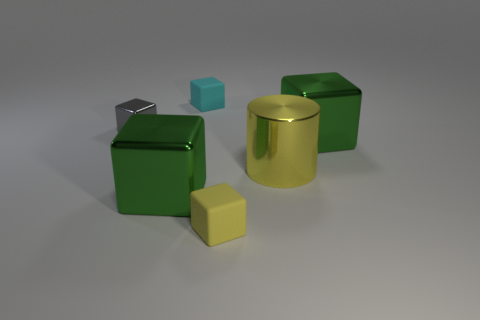How many objects are either tiny objects that are in front of the gray metallic thing or large cyan shiny spheres?
Provide a succinct answer. 1. Are there an equal number of shiny cylinders that are in front of the small gray metal object and big shiny cubes that are behind the large yellow object?
Offer a very short reply. Yes. There is a big green block that is on the right side of the large metallic cube left of the tiny matte object that is behind the small gray cube; what is its material?
Keep it short and to the point. Metal. What is the size of the cube that is behind the large metallic cylinder and on the left side of the cyan cube?
Offer a very short reply. Small. Does the gray thing have the same shape as the small cyan object?
Give a very brief answer. Yes. What is the shape of the tiny thing that is the same material as the cyan cube?
Offer a very short reply. Cube. What number of small objects are red matte objects or yellow metal objects?
Give a very brief answer. 0. There is a large shiny thing that is to the left of the cyan rubber thing; are there any tiny matte objects that are behind it?
Provide a short and direct response. Yes. Are any gray shiny blocks visible?
Ensure brevity in your answer.  Yes. The small matte block that is behind the yellow matte block to the right of the small cyan matte thing is what color?
Your answer should be compact. Cyan. 